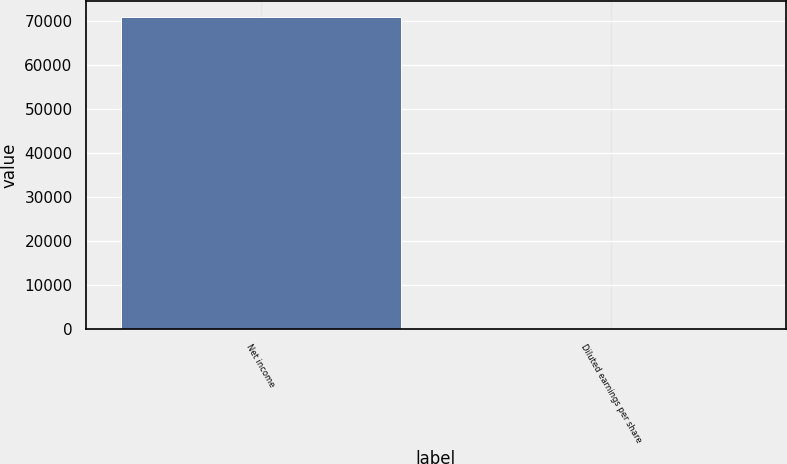Convert chart to OTSL. <chart><loc_0><loc_0><loc_500><loc_500><bar_chart><fcel>Net income<fcel>Diluted earnings per share<nl><fcel>70946<fcel>1<nl></chart> 